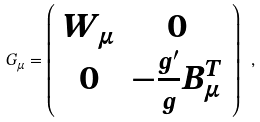<formula> <loc_0><loc_0><loc_500><loc_500>G _ { \mu } = \left ( \begin{array} { c c } W _ { \mu } & { 0 } \\ { 0 } & - \frac { g ^ { \prime } } { g } B _ { \mu } ^ { T } \end{array} \right ) \ ,</formula> 